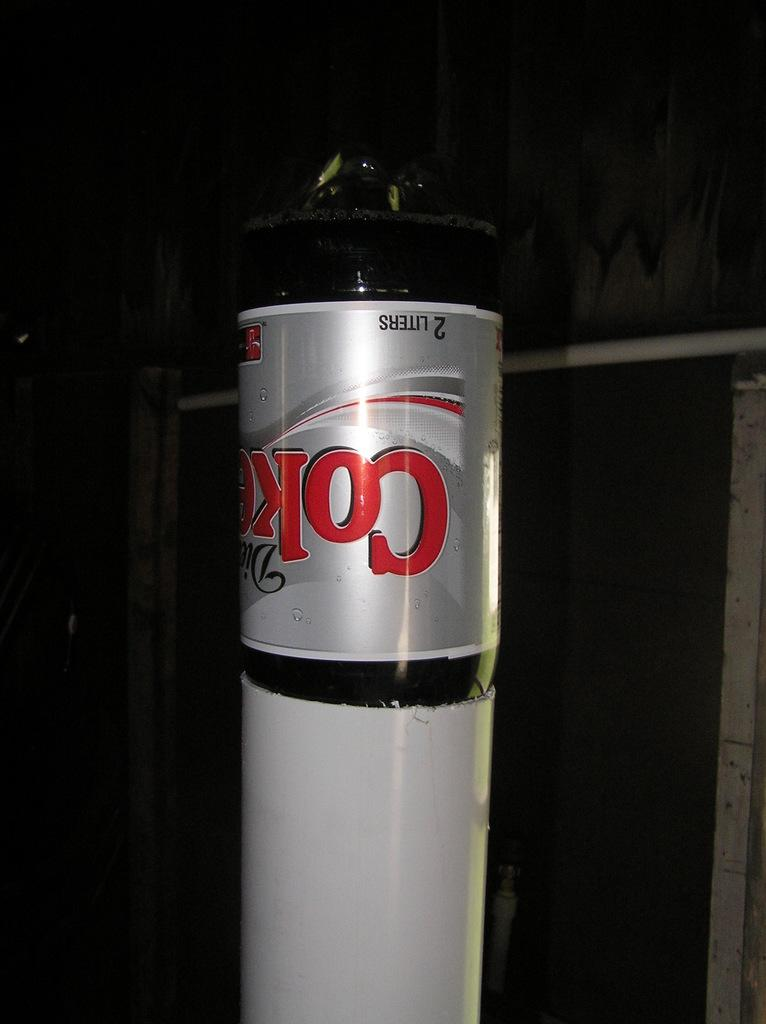<image>
Create a compact narrative representing the image presented. Coke bottle upside down with the word Liters on the bottom. 